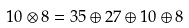Convert formula to latex. <formula><loc_0><loc_0><loc_500><loc_500>1 0 \otimes 8 = 3 5 \oplus 2 7 \oplus 1 0 \oplus 8</formula> 